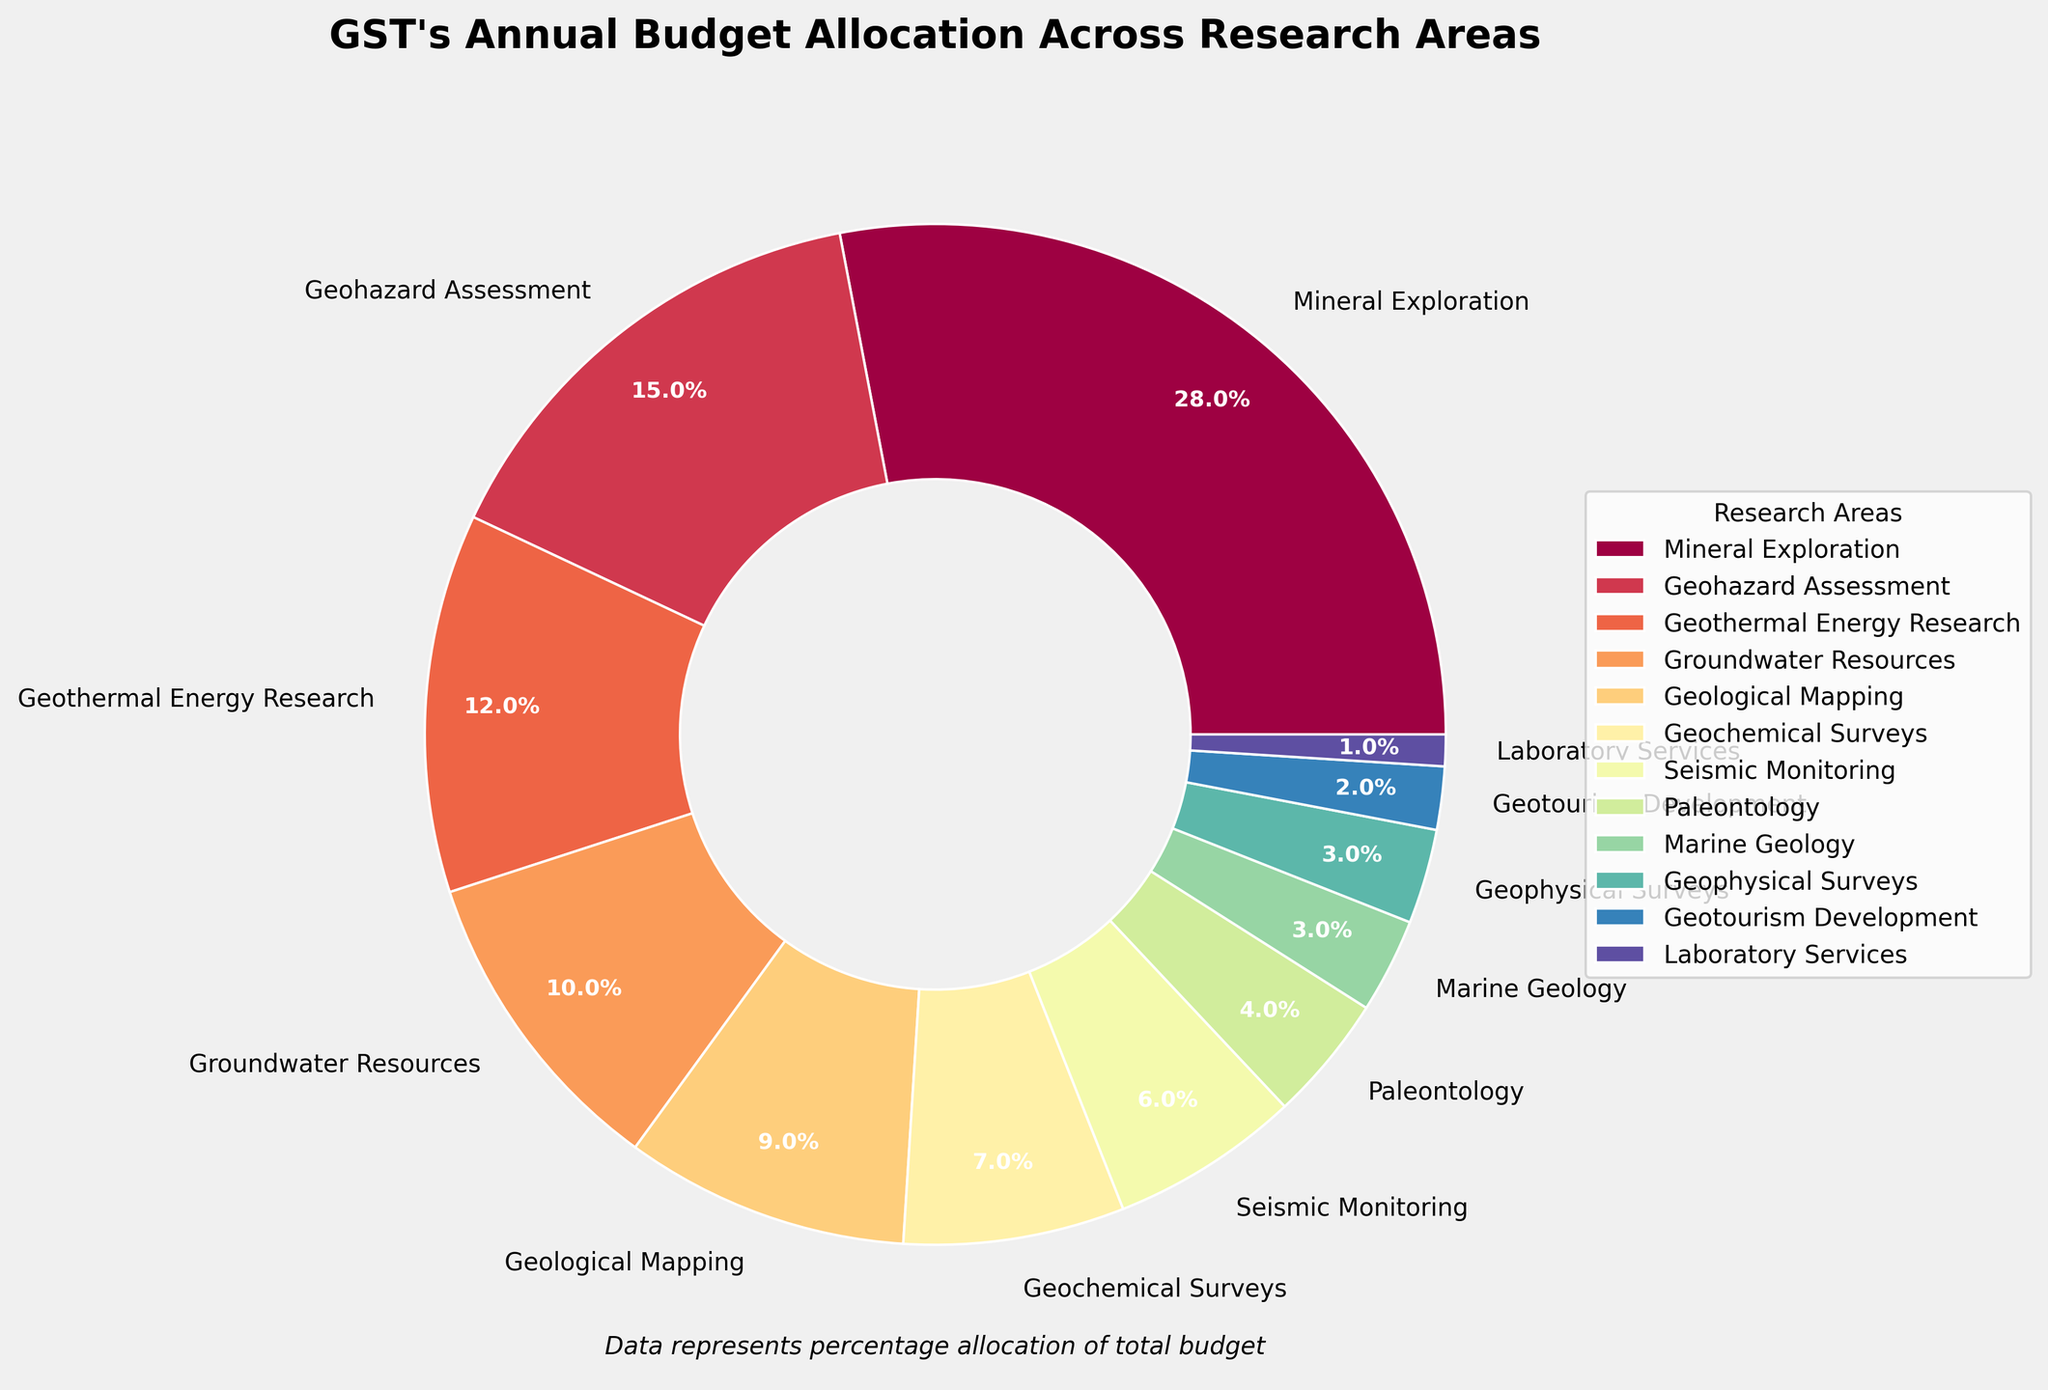What is the largest allocation in the GST's annual budget? The largest allocation is represented by the largest sector of the pie chart. Mineral Exploration occupies the largest sector with 28%.
Answer: Mineral Exploration Which two research areas have a combined budget allocation of 25%? By reviewing the pie chart, Geohazard Assessment has 15% and Geothermal Energy Research has 12%. Adding these two percentages together, we get 15% + 12% = 27%. Thus, we need to look further. The next two largest are Geological Mapping at 9% and Groundwater Resources at 10%, which totals 19%. No combination equals exactly 25%. The closest total is Geohazard Assessment (15%) and Geothermal Energy Research (12%), totaling 27%.
Answer: No exact pair summing to 25% How much more budget allocation does Mineral Exploration have than Groundwater Resources? Mineral Exploration has 28%, and Groundwater Resources has 10%. Subtracting the smaller percentage from the larger percentage, we get 28% - 10% = 18%.
Answer: 18% Which research area has the smallest budget allocation? By looking at the smallest sector in the pie chart, Laboratory Services has the smallest allocation at 1%.
Answer: Laboratory Services What is the total budget allocation for Geohazard Assessment, Geological Mapping, and Geochemical Surveys? Summing the budget allocations of these three areas: Geohazard Assessment (15%), Geological Mapping (9%), and Geochemical Surveys (7%) gives 15% + 9% + 7% = 31%.
Answer: 31% Which research areas have an equal budget allocation? By observing the size of the sectors in the pie chart, Marine Geology and Geophysical Surveys both have the same budget allocation of 3%.
Answer: Marine Geology and Geophysical Surveys By how much does the budget allocation for Geohazard Assessment exceed Seismic Monitoring? Geohazard Assessment has 15% and Seismic Monitoring has 6%. Subtracting Seismic Monitoring's allocation from Geohazard Assessment's allocation, we get 15% - 6% = 9%.
Answer: 9% Compare the combined budget allocation of Paleontology and Marine Geology to Geological Mapping. Paleontology has 4% and Marine Geology has 3%. Adding these two gives 4% + 3% = 7%. Geological Mapping has 9%. Comparing these, 9% (Geological Mapping) is greater than 7% (combined Paleontology and Marine Geology).
Answer: Geological Mapping Which area of research has the closest budget allocation to Seismic Monitoring? Seismic Monitoring has 6%. The nearest allocation is Paleontology with 4%, which is 2% different.
Answer: Paleontology Which color represents Geothermal Energy Research in the pie chart? Visual information based on the pie chart indicates that the color specific to Geothermal Energy Research would typically be closer to the midpoint hue value in the color scale, often a distinct shade distinguishable from those immediately adjacent to it on the pie chart legend. Without specific color codes, it is identified by its position relative to other sectors.
Answer: Midpoint on the color scale 